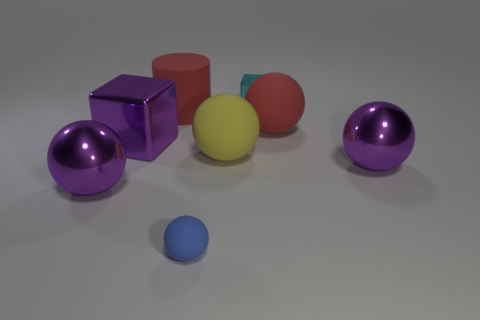Subtract 3 spheres. How many spheres are left? 2 Add 1 small yellow cylinders. How many objects exist? 9 Subtract all yellow balls. How many balls are left? 4 Subtract all red spheres. How many spheres are left? 4 Subtract all red spheres. Subtract all blue cylinders. How many spheres are left? 4 Subtract all cubes. How many objects are left? 6 Subtract all yellow rubber spheres. Subtract all small cyan objects. How many objects are left? 6 Add 3 tiny metallic things. How many tiny metallic things are left? 4 Add 6 purple metallic objects. How many purple metallic objects exist? 9 Subtract 0 green cylinders. How many objects are left? 8 